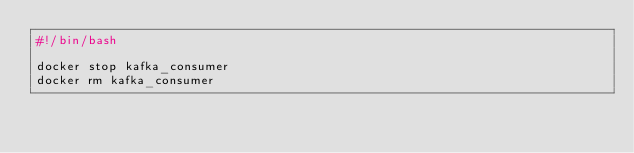<code> <loc_0><loc_0><loc_500><loc_500><_Bash_>#!/bin/bash

docker stop kafka_consumer
docker rm kafka_consumer
</code> 